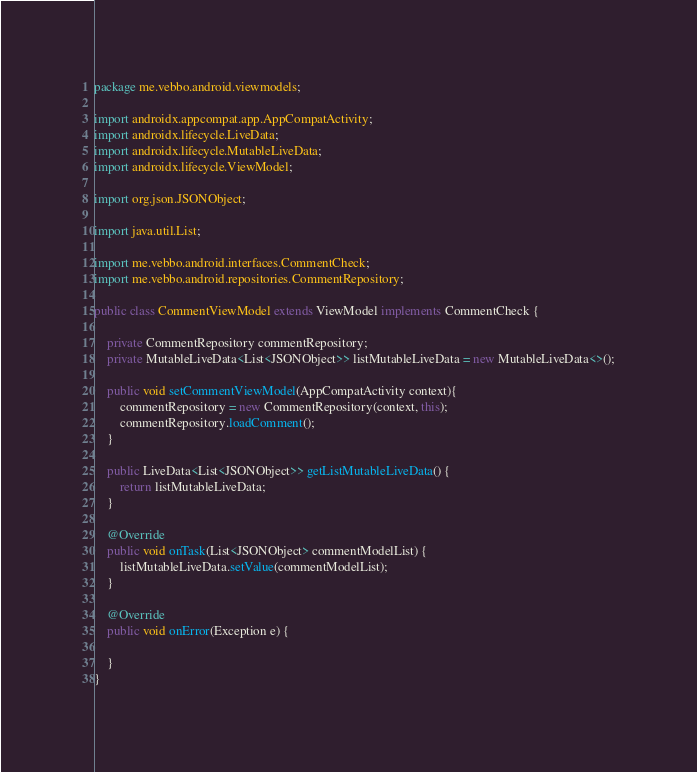<code> <loc_0><loc_0><loc_500><loc_500><_Java_>package me.vebbo.android.viewmodels;

import androidx.appcompat.app.AppCompatActivity;
import androidx.lifecycle.LiveData;
import androidx.lifecycle.MutableLiveData;
import androidx.lifecycle.ViewModel;

import org.json.JSONObject;

import java.util.List;

import me.vebbo.android.interfaces.CommentCheck;
import me.vebbo.android.repositories.CommentRepository;

public class CommentViewModel extends ViewModel implements CommentCheck {

    private CommentRepository commentRepository;
    private MutableLiveData<List<JSONObject>> listMutableLiveData = new MutableLiveData<>();

    public void setCommentViewModel(AppCompatActivity context){
        commentRepository = new CommentRepository(context, this);
        commentRepository.loadComment();
    }

    public LiveData<List<JSONObject>> getListMutableLiveData() {
        return listMutableLiveData;
    }

    @Override
    public void onTask(List<JSONObject> commentModelList) {
        listMutableLiveData.setValue(commentModelList);
    }

    @Override
    public void onError(Exception e) {

    }
}
</code> 